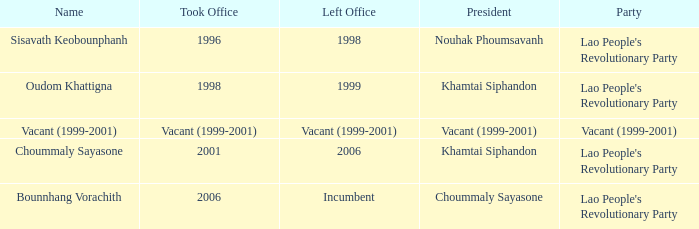What is the name, when the president is khamtai siphandon, and when departed office is 1999? Oudom Khattigna. Write the full table. {'header': ['Name', 'Took Office', 'Left Office', 'President', 'Party'], 'rows': [['Sisavath Keobounphanh', '1996', '1998', 'Nouhak Phoumsavanh', "Lao People's Revolutionary Party"], ['Oudom Khattigna', '1998', '1999', 'Khamtai Siphandon', "Lao People's Revolutionary Party"], ['Vacant (1999-2001)', 'Vacant (1999-2001)', 'Vacant (1999-2001)', 'Vacant (1999-2001)', 'Vacant (1999-2001)'], ['Choummaly Sayasone', '2001', '2006', 'Khamtai Siphandon', "Lao People's Revolutionary Party"], ['Bounnhang Vorachith', '2006', 'Incumbent', 'Choummaly Sayasone', "Lao People's Revolutionary Party"]]} 